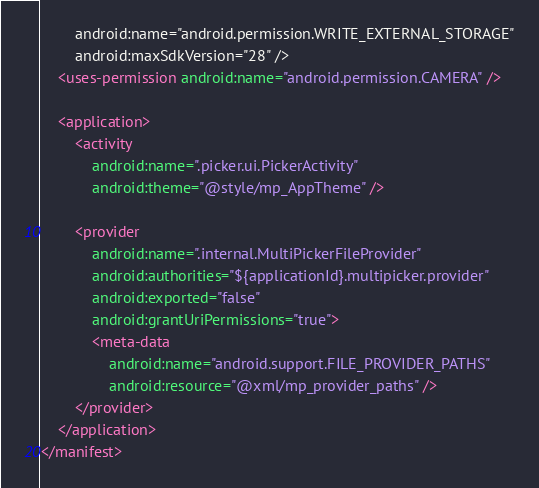Convert code to text. <code><loc_0><loc_0><loc_500><loc_500><_XML_>        android:name="android.permission.WRITE_EXTERNAL_STORAGE"
        android:maxSdkVersion="28" />
    <uses-permission android:name="android.permission.CAMERA" />

    <application>
        <activity
            android:name=".picker.ui.PickerActivity"
            android:theme="@style/mp_AppTheme" />

        <provider
            android:name=".internal.MultiPickerFileProvider"
            android:authorities="${applicationId}.multipicker.provider"
            android:exported="false"
            android:grantUriPermissions="true">
            <meta-data
                android:name="android.support.FILE_PROVIDER_PATHS"
                android:resource="@xml/mp_provider_paths" />
        </provider>
    </application>
</manifest>
</code> 